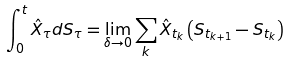<formula> <loc_0><loc_0><loc_500><loc_500>\int _ { 0 } ^ { t } \hat { X } _ { \tau } d S _ { \tau } = \lim _ { \delta \to 0 } \sum _ { k } \hat { X } _ { t _ { k } } \left ( S _ { t _ { k + 1 } } - S _ { t _ { k } } \right )</formula> 